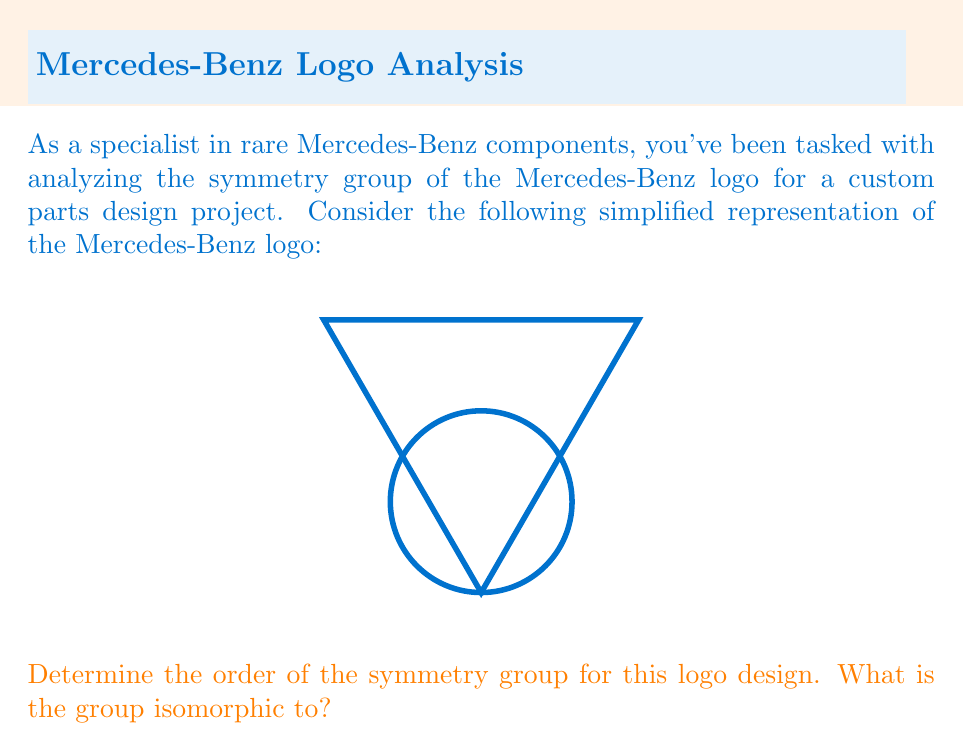Solve this math problem. Let's analyze the symmetry group of the Mercedes-Benz logo step by step:

1) First, we need to identify all the symmetries of the logo:
   a) Rotational symmetries: The logo has 3-fold rotational symmetry (120° rotations).
   b) Reflection symmetries: There are 3 lines of reflection (through each point of the triangle).

2) Let's count the elements of the symmetry group:
   - The identity transformation (no change)
   - Two 120° rotations (clockwise and counterclockwise)
   - Three reflections (one for each line of symmetry)

   Total: 1 + 2 + 3 = 6 elements

3) The order of the symmetry group is therefore 6.

4) To determine which group this is isomorphic to, we need to consider groups of order 6:
   - The cyclic group $C_6$
   - The dihedral group $D_3$

5) Since our group has both rotations and reflections, it cannot be cyclic. It must be the dihedral group $D_3$.

6) The dihedral group $D_3$ is defined as:
   $$D_3 = \langle r, s | r^3 = s^2 = 1, srs = r^{-1} \rangle$$
   Where $r$ represents a 120° rotation and $s$ represents a reflection.

Therefore, the symmetry group of the Mercedes-Benz logo is isomorphic to the dihedral group $D_3$.
Answer: Order 6, isomorphic to $D_3$ 